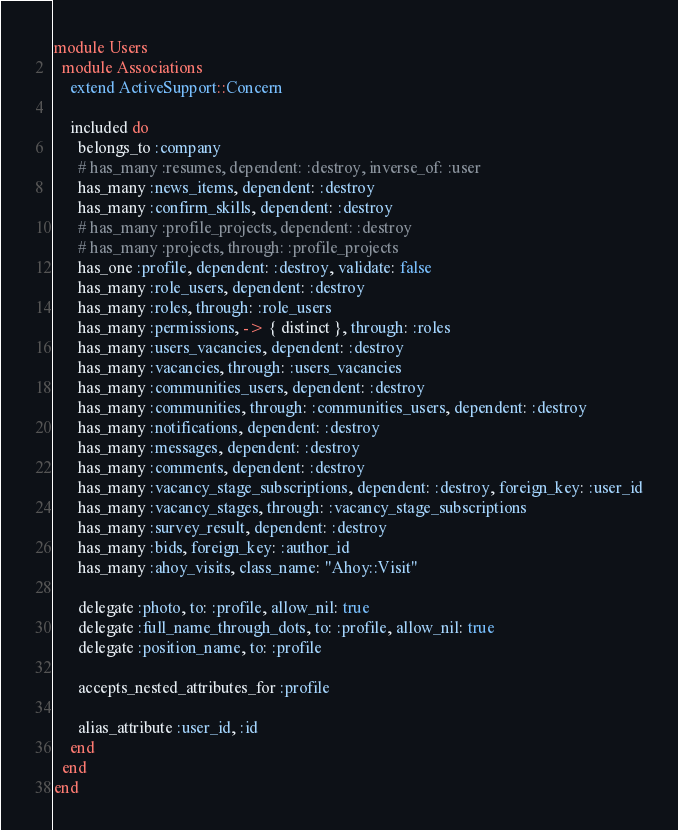<code> <loc_0><loc_0><loc_500><loc_500><_Ruby_>module Users
  module Associations
    extend ActiveSupport::Concern

    included do
      belongs_to :company
      # has_many :resumes, dependent: :destroy, inverse_of: :user
      has_many :news_items, dependent: :destroy
      has_many :confirm_skills, dependent: :destroy
      # has_many :profile_projects, dependent: :destroy
      # has_many :projects, through: :profile_projects
      has_one :profile, dependent: :destroy, validate: false
      has_many :role_users, dependent: :destroy
      has_many :roles, through: :role_users
      has_many :permissions, -> { distinct }, through: :roles
      has_many :users_vacancies, dependent: :destroy
      has_many :vacancies, through: :users_vacancies
      has_many :communities_users, dependent: :destroy
      has_many :communities, through: :communities_users, dependent: :destroy
      has_many :notifications, dependent: :destroy
      has_many :messages, dependent: :destroy
      has_many :comments, dependent: :destroy
      has_many :vacancy_stage_subscriptions, dependent: :destroy, foreign_key: :user_id
      has_many :vacancy_stages, through: :vacancy_stage_subscriptions
      has_many :survey_result, dependent: :destroy
      has_many :bids, foreign_key: :author_id
      has_many :ahoy_visits, class_name: "Ahoy::Visit"

      delegate :photo, to: :profile, allow_nil: true
      delegate :full_name_through_dots, to: :profile, allow_nil: true
      delegate :position_name, to: :profile

      accepts_nested_attributes_for :profile

      alias_attribute :user_id, :id
    end
  end
end</code> 